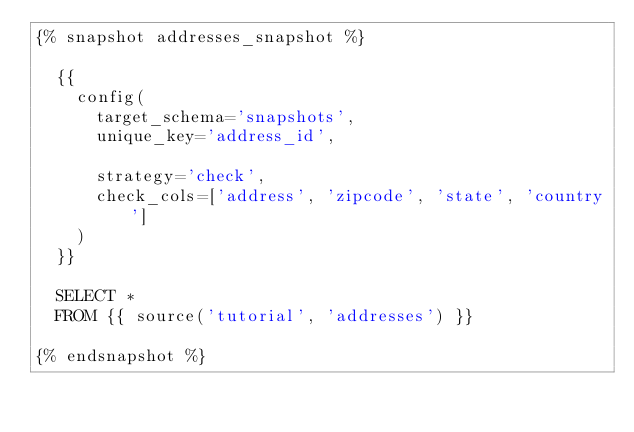<code> <loc_0><loc_0><loc_500><loc_500><_SQL_>{% snapshot addresses_snapshot %}

  {{
    config(
      target_schema='snapshots',
      unique_key='address_id',

      strategy='check',
      check_cols=['address', 'zipcode', 'state', 'country']
    )
  }}

  SELECT * 
  FROM {{ source('tutorial', 'addresses') }}

{% endsnapshot %}</code> 